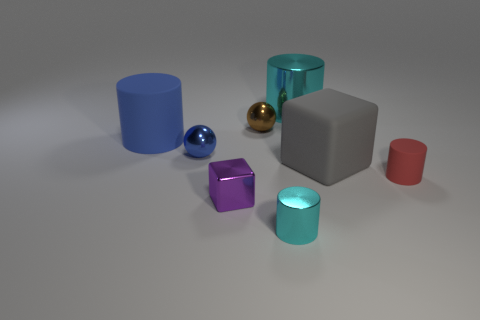Are there fewer gray matte things behind the matte block than brown metal objects?
Keep it short and to the point. Yes. Does the big object left of the large cyan thing have the same material as the large gray object?
Your response must be concise. Yes. There is a tiny cylinder that is made of the same material as the tiny purple block; what is its color?
Ensure brevity in your answer.  Cyan. Are there fewer metal cubes that are in front of the small brown ball than small cyan cylinders that are behind the purple shiny object?
Make the answer very short. No. There is a metallic thing on the left side of the purple block; is its color the same as the large rubber thing left of the purple metal object?
Provide a short and direct response. Yes. Is there a red cylinder that has the same material as the tiny cyan cylinder?
Give a very brief answer. No. What is the size of the cyan metal thing behind the large matte object that is right of the brown metallic ball?
Make the answer very short. Large. Is the number of large spheres greater than the number of tiny red rubber objects?
Your response must be concise. No. There is a cyan thing that is in front of the red cylinder; is its size the same as the blue metallic sphere?
Offer a very short reply. Yes. How many small objects are the same color as the large block?
Keep it short and to the point. 0. 